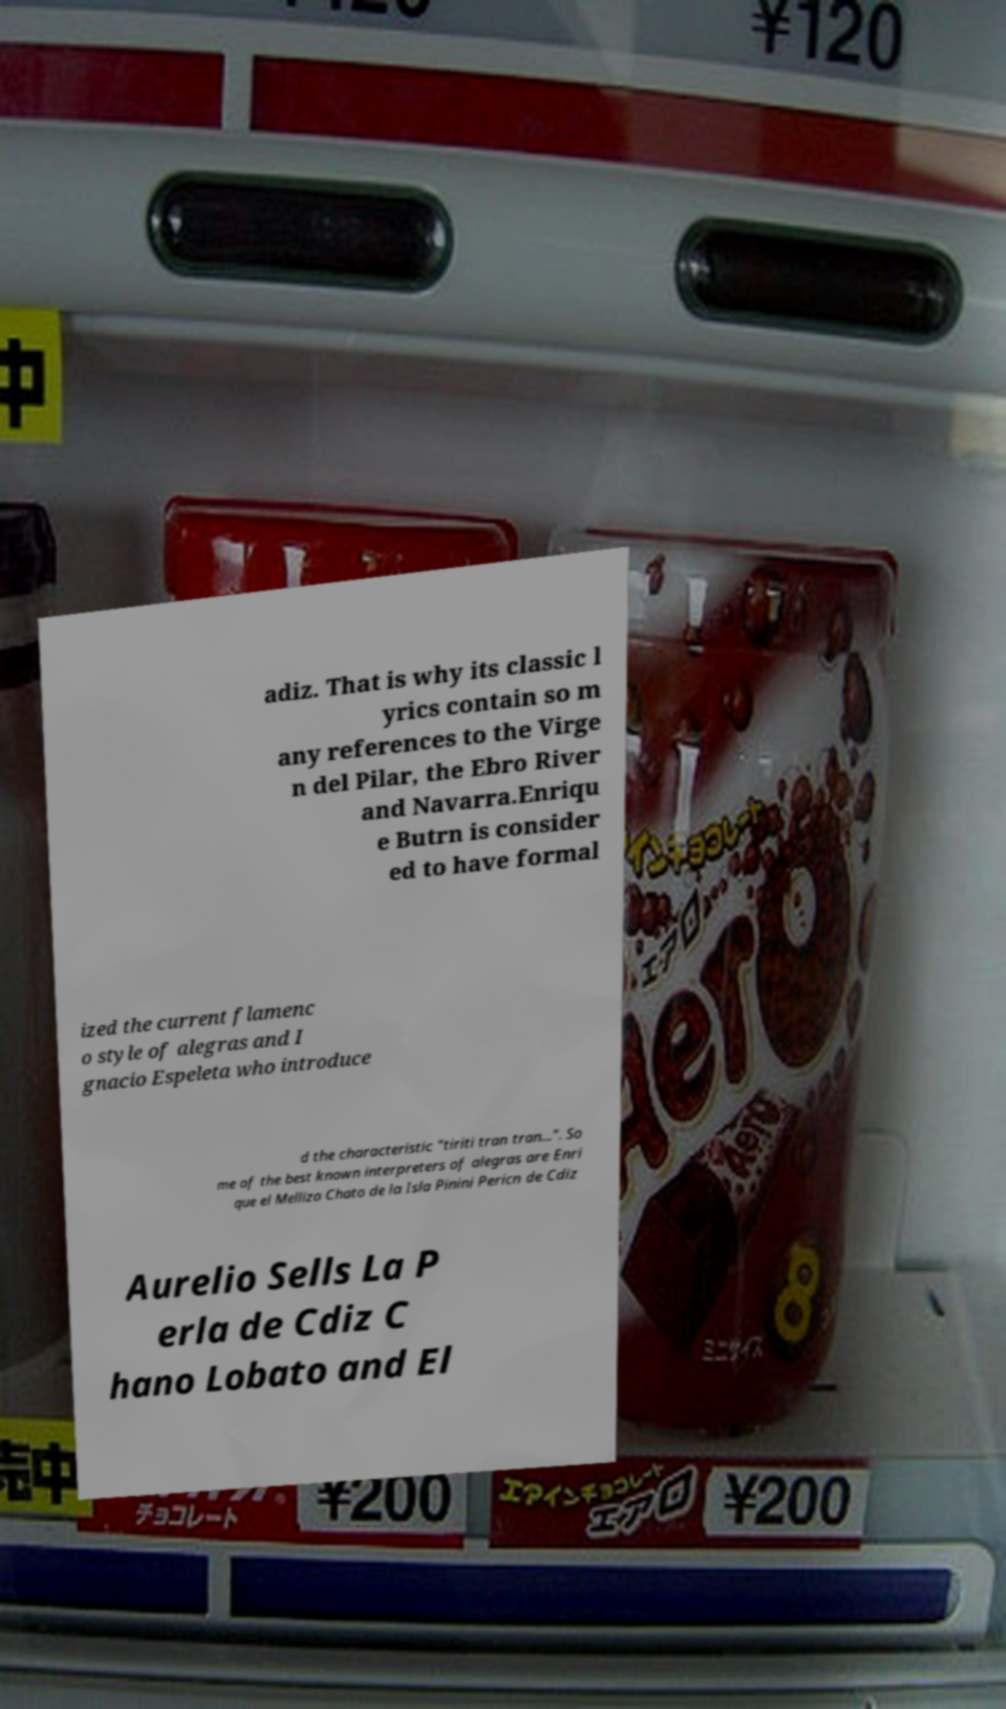I need the written content from this picture converted into text. Can you do that? adiz. That is why its classic l yrics contain so m any references to the Virge n del Pilar, the Ebro River and Navarra.Enriqu e Butrn is consider ed to have formal ized the current flamenc o style of alegras and I gnacio Espeleta who introduce d the characteristic "tiriti tran tran...". So me of the best known interpreters of alegras are Enri que el Mellizo Chato de la Isla Pinini Pericn de Cdiz Aurelio Sells La P erla de Cdiz C hano Lobato and El 